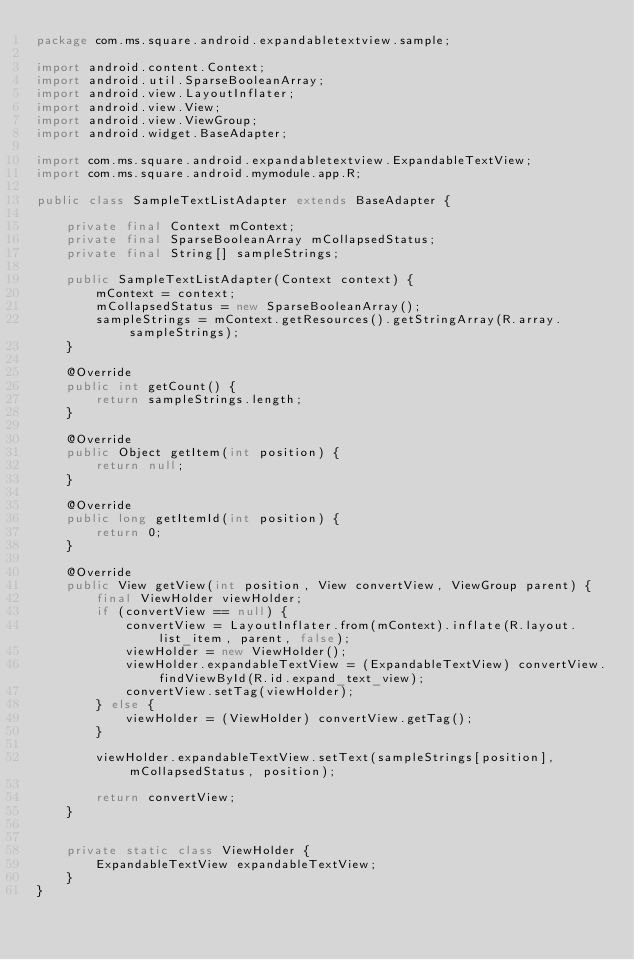Convert code to text. <code><loc_0><loc_0><loc_500><loc_500><_Java_>package com.ms.square.android.expandabletextview.sample;

import android.content.Context;
import android.util.SparseBooleanArray;
import android.view.LayoutInflater;
import android.view.View;
import android.view.ViewGroup;
import android.widget.BaseAdapter;

import com.ms.square.android.expandabletextview.ExpandableTextView;
import com.ms.square.android.mymodule.app.R;

public class SampleTextListAdapter extends BaseAdapter {

    private final Context mContext;
    private final SparseBooleanArray mCollapsedStatus;
    private final String[] sampleStrings;

    public SampleTextListAdapter(Context context) {
        mContext = context;
        mCollapsedStatus = new SparseBooleanArray();
        sampleStrings = mContext.getResources().getStringArray(R.array.sampleStrings);
    }

    @Override
    public int getCount() {
        return sampleStrings.length;
    }

    @Override
    public Object getItem(int position) {
        return null;
    }

    @Override
    public long getItemId(int position) {
        return 0;
    }

    @Override
    public View getView(int position, View convertView, ViewGroup parent) {
        final ViewHolder viewHolder;
        if (convertView == null) {
            convertView = LayoutInflater.from(mContext).inflate(R.layout.list_item, parent, false);
            viewHolder = new ViewHolder();
            viewHolder.expandableTextView = (ExpandableTextView) convertView.findViewById(R.id.expand_text_view);
            convertView.setTag(viewHolder);
        } else {
            viewHolder = (ViewHolder) convertView.getTag();
        }

        viewHolder.expandableTextView.setText(sampleStrings[position], mCollapsedStatus, position);

        return convertView;
    }


    private static class ViewHolder {
        ExpandableTextView expandableTextView;
    }
}</code> 